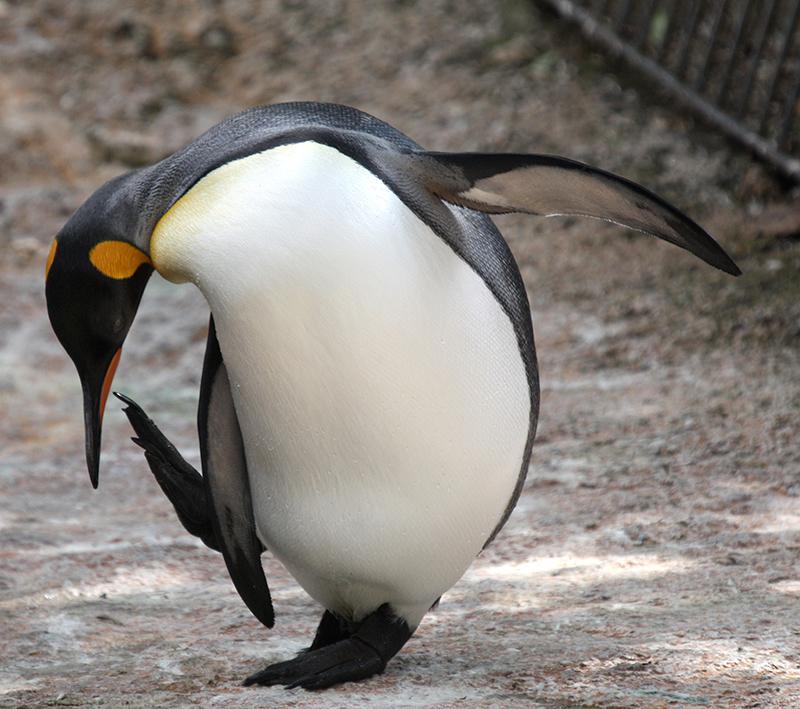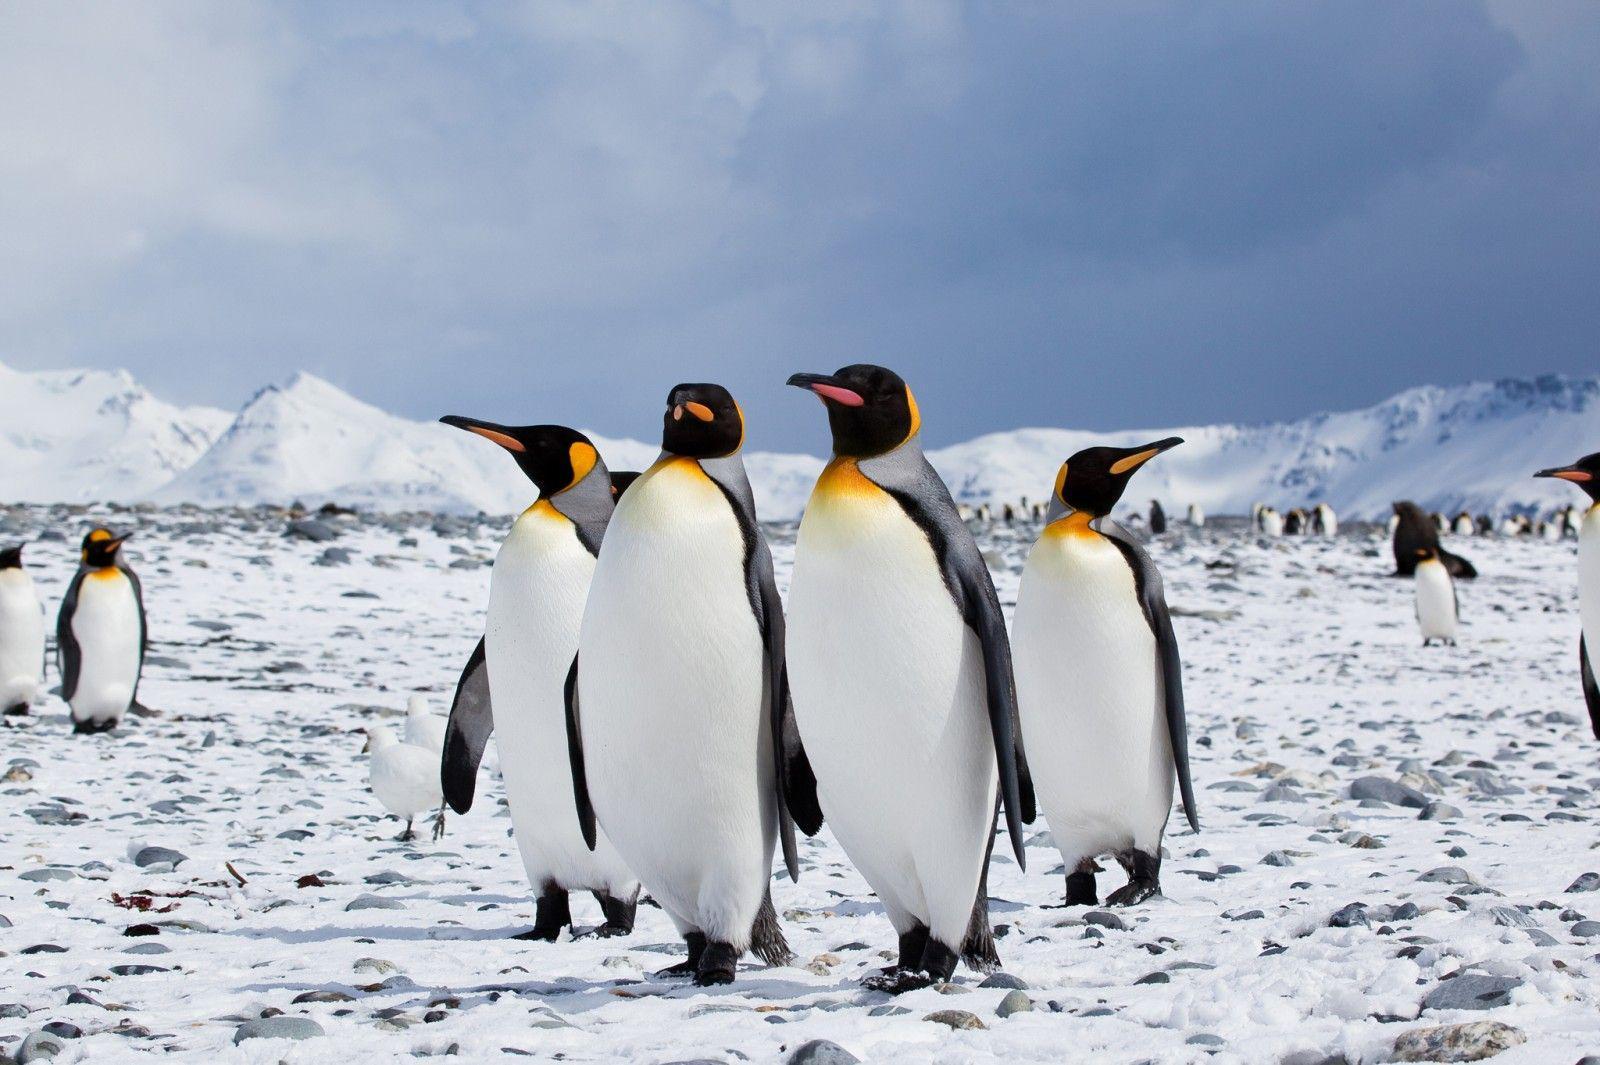The first image is the image on the left, the second image is the image on the right. Analyze the images presented: Is the assertion "There is exactly one penguin in the image on the right." valid? Answer yes or no. No. 